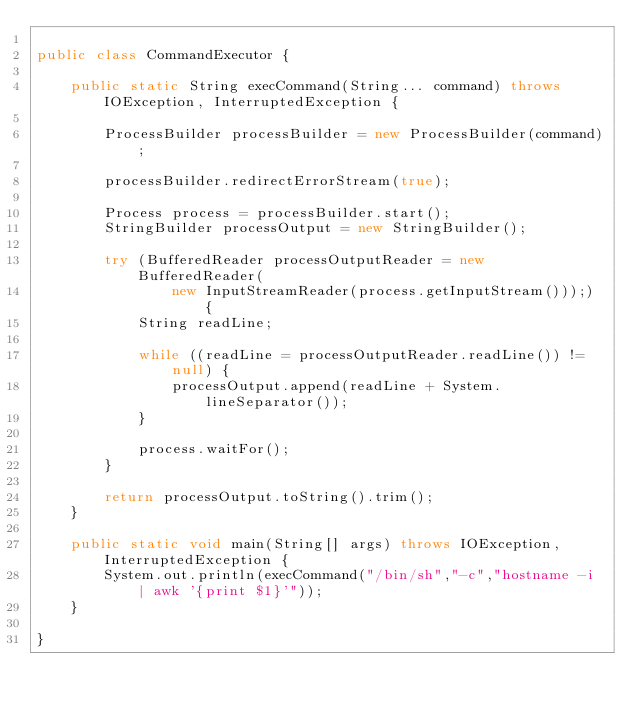<code> <loc_0><loc_0><loc_500><loc_500><_Java_>
public class CommandExecutor {

	public static String execCommand(String... command) throws IOException, InterruptedException {

		ProcessBuilder processBuilder = new ProcessBuilder(command);

		processBuilder.redirectErrorStream(true);

		Process process = processBuilder.start();
		StringBuilder processOutput = new StringBuilder();

		try (BufferedReader processOutputReader = new BufferedReader(
				new InputStreamReader(process.getInputStream()));) {
			String readLine;

			while ((readLine = processOutputReader.readLine()) != null) {
				processOutput.append(readLine + System.lineSeparator());
			}

			process.waitFor();
		}

		return processOutput.toString().trim();
	}
	
	public static void main(String[] args) throws IOException, InterruptedException {
		System.out.println(execCommand("/bin/sh","-c","hostname -i | awk '{print $1}'"));
	}

}
</code> 